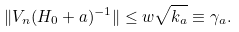Convert formula to latex. <formula><loc_0><loc_0><loc_500><loc_500>\| V _ { n } ( H _ { 0 } + a ) ^ { - 1 } \| \leq w \sqrt { k _ { a } } \equiv \gamma _ { a } .</formula> 